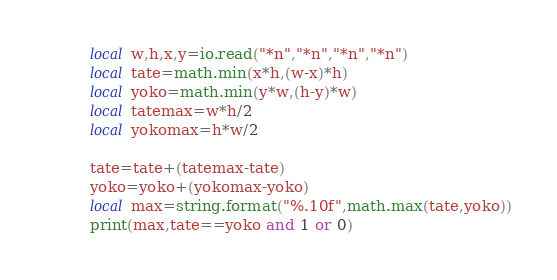Convert code to text. <code><loc_0><loc_0><loc_500><loc_500><_Lua_>local w,h,x,y=io.read("*n","*n","*n","*n")
local tate=math.min(x*h,(w-x)*h)
local yoko=math.min(y*w,(h-y)*w)
local tatemax=w*h/2
local yokomax=h*w/2

tate=tate+(tatemax-tate)
yoko=yoko+(yokomax-yoko)
local max=string.format("%.10f",math.max(tate,yoko))
print(max,tate==yoko and 1 or 0)</code> 